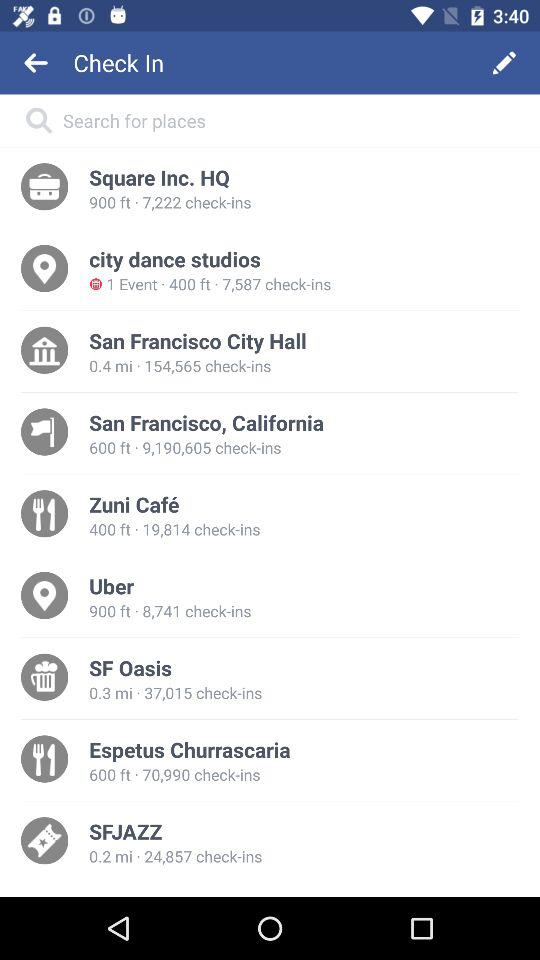What is the closest location?
When the provided information is insufficient, respond with <no answer>. <no answer> 